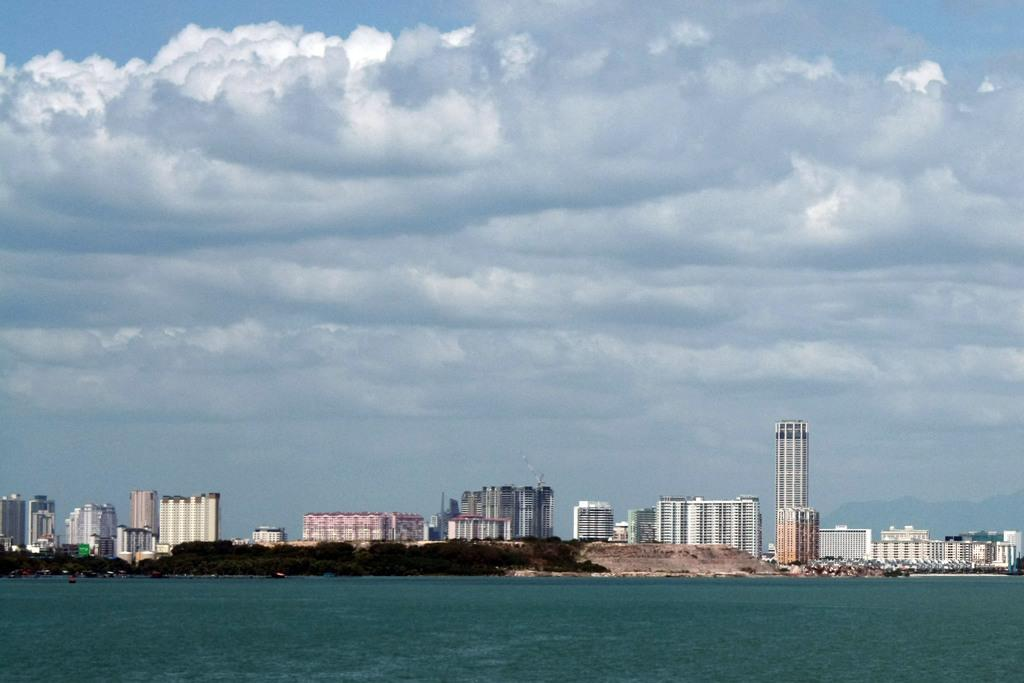What type of structures can be seen in the image? There are buildings in the image. What natural element is visible in the image? There is water visible in the image. What can be seen in the background of the image? The sky is visible in the background of the image. What type of beef is being served in the image? There is no beef present in the image; it features buildings, water, and the sky. 